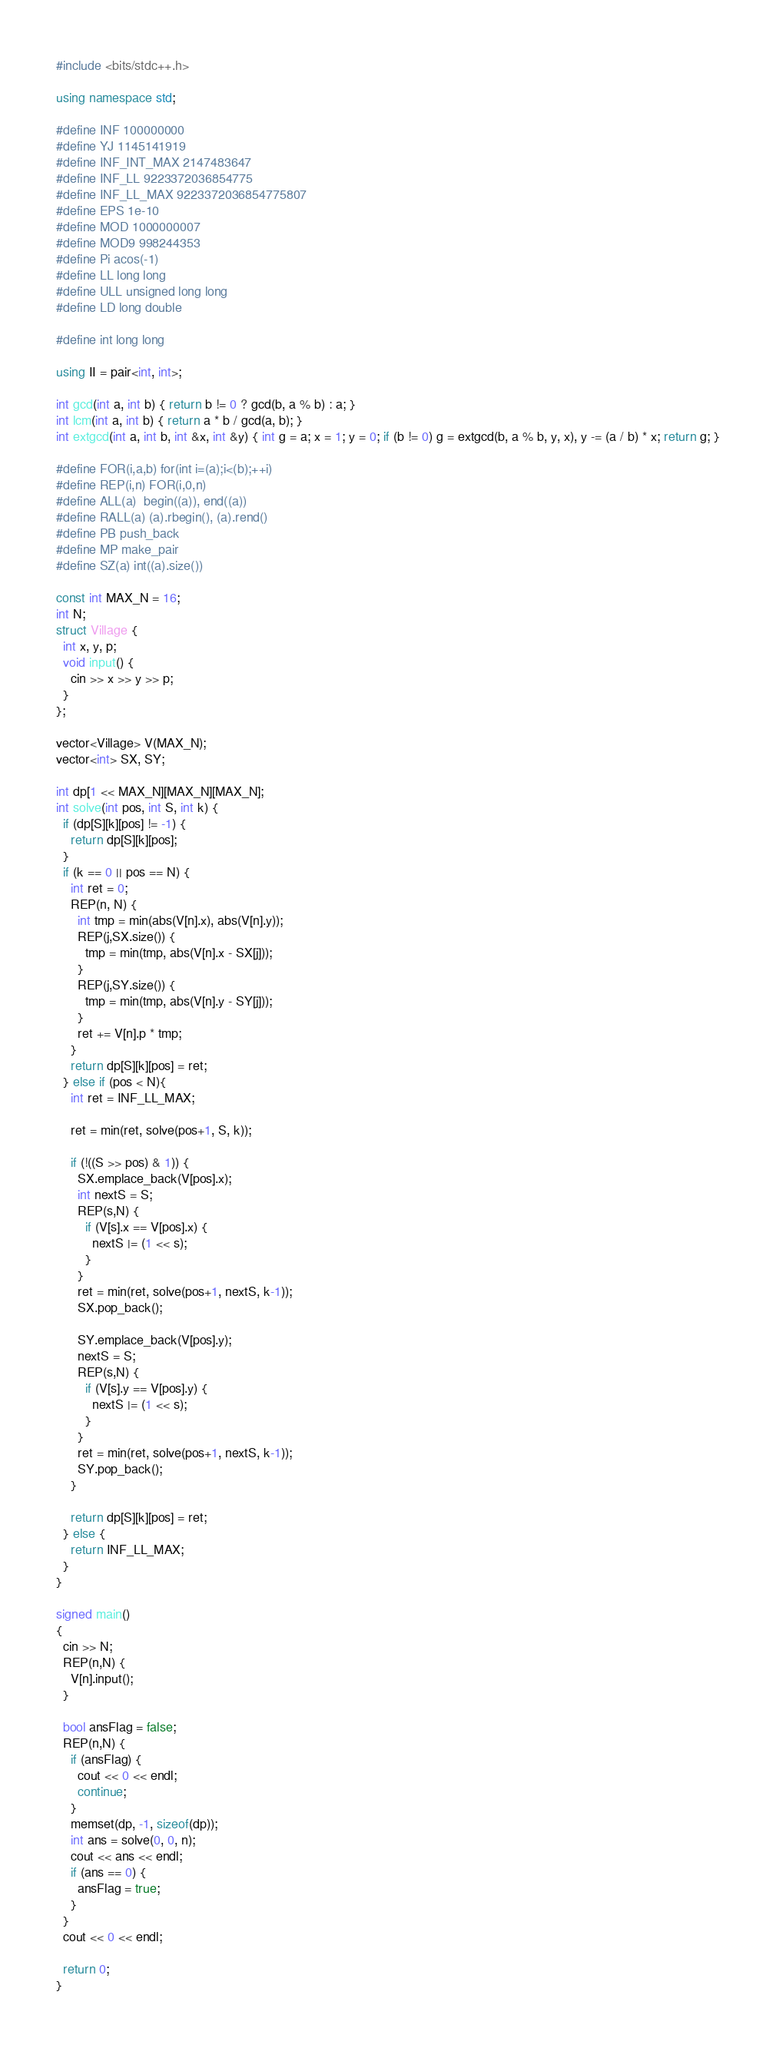<code> <loc_0><loc_0><loc_500><loc_500><_C++_>#include <bits/stdc++.h>

using namespace std;

#define INF 100000000
#define YJ 1145141919
#define INF_INT_MAX 2147483647
#define INF_LL 9223372036854775
#define INF_LL_MAX 9223372036854775807
#define EPS 1e-10
#define MOD 1000000007
#define MOD9 998244353
#define Pi acos(-1)
#define LL long long
#define ULL unsigned long long
#define LD long double

#define int long long

using II = pair<int, int>;

int gcd(int a, int b) { return b != 0 ? gcd(b, a % b) : a; }
int lcm(int a, int b) { return a * b / gcd(a, b); }
int extgcd(int a, int b, int &x, int &y) { int g = a; x = 1; y = 0; if (b != 0) g = extgcd(b, a % b, y, x), y -= (a / b) * x; return g; }

#define FOR(i,a,b) for(int i=(a);i<(b);++i)
#define REP(i,n) FOR(i,0,n)
#define ALL(a)  begin((a)), end((a))
#define RALL(a) (a).rbegin(), (a).rend()
#define PB push_back
#define MP make_pair
#define SZ(a) int((a).size())

const int MAX_N = 16;
int N;
struct Village {
  int x, y, p;
  void input() {
    cin >> x >> y >> p;
  }
};

vector<Village> V(MAX_N);
vector<int> SX, SY;

int dp[1 << MAX_N][MAX_N][MAX_N];
int solve(int pos, int S, int k) {
  if (dp[S][k][pos] != -1) {
    return dp[S][k][pos];
  }
  if (k == 0 || pos == N) {
    int ret = 0;
    REP(n, N) {
      int tmp = min(abs(V[n].x), abs(V[n].y));
      REP(j,SX.size()) {
        tmp = min(tmp, abs(V[n].x - SX[j]));
      }
      REP(j,SY.size()) {
        tmp = min(tmp, abs(V[n].y - SY[j]));
      }
      ret += V[n].p * tmp;
    }
    return dp[S][k][pos] = ret;
  } else if (pos < N){
    int ret = INF_LL_MAX;

    ret = min(ret, solve(pos+1, S, k));

    if (!((S >> pos) & 1)) {
      SX.emplace_back(V[pos].x);
      int nextS = S;
      REP(s,N) {
        if (V[s].x == V[pos].x) {
          nextS |= (1 << s);
        }
      }
      ret = min(ret, solve(pos+1, nextS, k-1));
      SX.pop_back();

      SY.emplace_back(V[pos].y);
      nextS = S;
      REP(s,N) {
        if (V[s].y == V[pos].y) {
          nextS |= (1 << s);
        }
      }
      ret = min(ret, solve(pos+1, nextS, k-1));
      SY.pop_back();
    }

    return dp[S][k][pos] = ret;
  } else {
    return INF_LL_MAX;
  }
}

signed main()
{
  cin >> N;
  REP(n,N) {
    V[n].input();
  }

  bool ansFlag = false;
  REP(n,N) {
    if (ansFlag) {
      cout << 0 << endl;
      continue;
    }
    memset(dp, -1, sizeof(dp));
    int ans = solve(0, 0, n);
    cout << ans << endl;
    if (ans == 0) {
      ansFlag = true;
    }
  }
  cout << 0 << endl;

  return 0;
}

</code> 